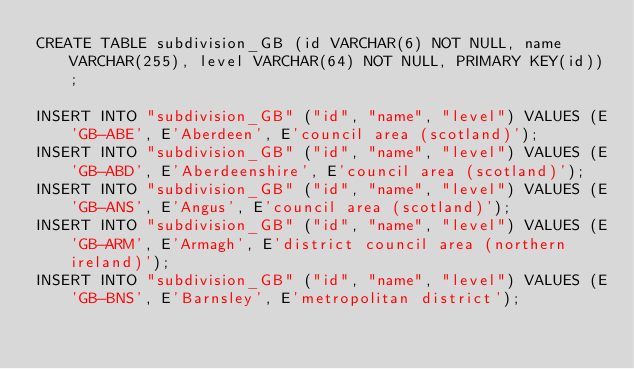<code> <loc_0><loc_0><loc_500><loc_500><_SQL_>CREATE TABLE subdivision_GB (id VARCHAR(6) NOT NULL, name VARCHAR(255), level VARCHAR(64) NOT NULL, PRIMARY KEY(id));

INSERT INTO "subdivision_GB" ("id", "name", "level") VALUES (E'GB-ABE', E'Aberdeen', E'council area (scotland)');
INSERT INTO "subdivision_GB" ("id", "name", "level") VALUES (E'GB-ABD', E'Aberdeenshire', E'council area (scotland)');
INSERT INTO "subdivision_GB" ("id", "name", "level") VALUES (E'GB-ANS', E'Angus', E'council area (scotland)');
INSERT INTO "subdivision_GB" ("id", "name", "level") VALUES (E'GB-ARM', E'Armagh', E'district council area (northern ireland)');
INSERT INTO "subdivision_GB" ("id", "name", "level") VALUES (E'GB-BNS', E'Barnsley', E'metropolitan district');</code> 